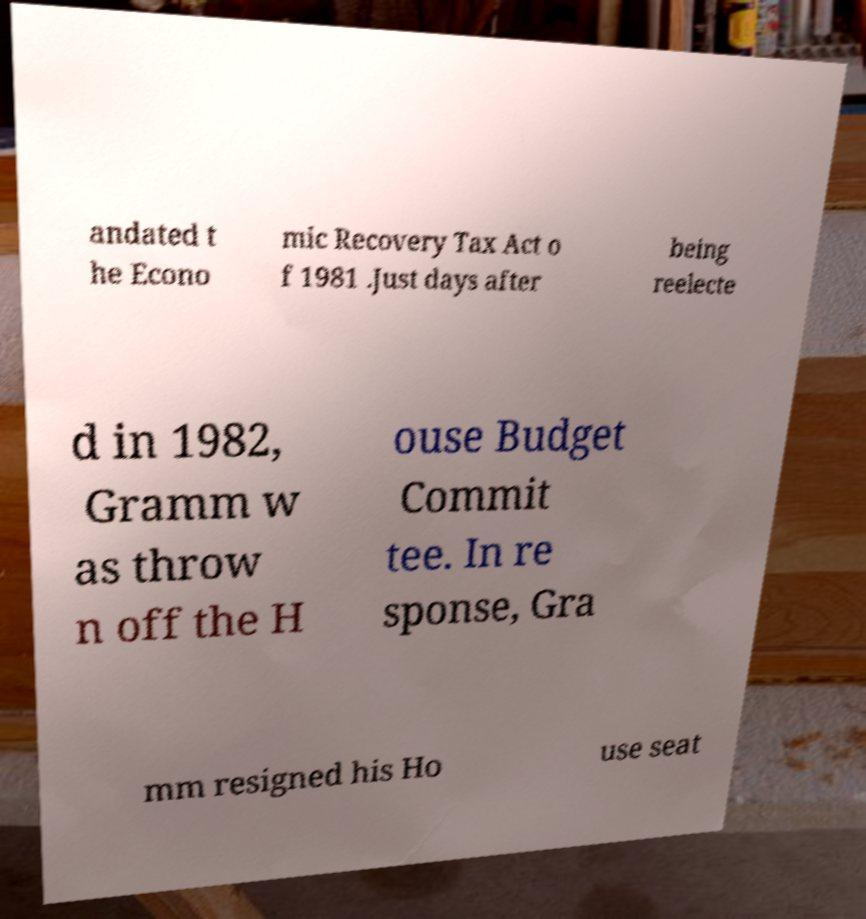There's text embedded in this image that I need extracted. Can you transcribe it verbatim? andated t he Econo mic Recovery Tax Act o f 1981 .Just days after being reelecte d in 1982, Gramm w as throw n off the H ouse Budget Commit tee. In re sponse, Gra mm resigned his Ho use seat 